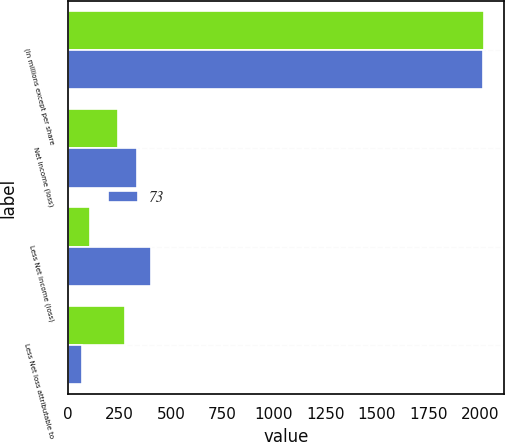Convert chart to OTSL. <chart><loc_0><loc_0><loc_500><loc_500><stacked_bar_chart><ecel><fcel>(In millions except per share<fcel>Net income (loss)<fcel>Less Net income (loss)<fcel>Less Net loss attributable to<nl><fcel>nan<fcel>2017<fcel>242<fcel>109<fcel>278<nl><fcel>73<fcel>2016<fcel>334<fcel>403<fcel>69<nl></chart> 